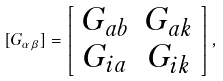<formula> <loc_0><loc_0><loc_500><loc_500>[ G _ { \alpha \beta } ] = \left [ \begin{array} { c c } G _ { a b } & G _ { a k } \\ G _ { i a } & G _ { i k } \end{array} \right ] ,</formula> 